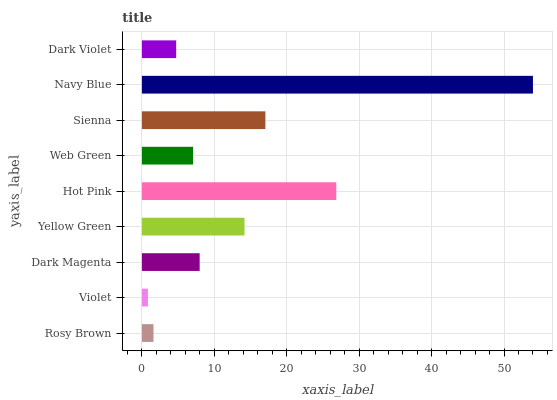Is Violet the minimum?
Answer yes or no. Yes. Is Navy Blue the maximum?
Answer yes or no. Yes. Is Dark Magenta the minimum?
Answer yes or no. No. Is Dark Magenta the maximum?
Answer yes or no. No. Is Dark Magenta greater than Violet?
Answer yes or no. Yes. Is Violet less than Dark Magenta?
Answer yes or no. Yes. Is Violet greater than Dark Magenta?
Answer yes or no. No. Is Dark Magenta less than Violet?
Answer yes or no. No. Is Dark Magenta the high median?
Answer yes or no. Yes. Is Dark Magenta the low median?
Answer yes or no. Yes. Is Rosy Brown the high median?
Answer yes or no. No. Is Sienna the low median?
Answer yes or no. No. 